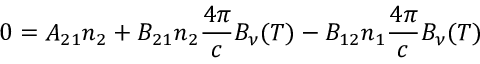Convert formula to latex. <formula><loc_0><loc_0><loc_500><loc_500>0 = A _ { 2 1 } n _ { 2 } + B _ { 2 1 } n _ { 2 } { \frac { 4 \pi } { c } } B _ { \nu } ( T ) - B _ { 1 2 } n _ { 1 } { \frac { 4 \pi } { c } } B _ { \nu } ( T )</formula> 